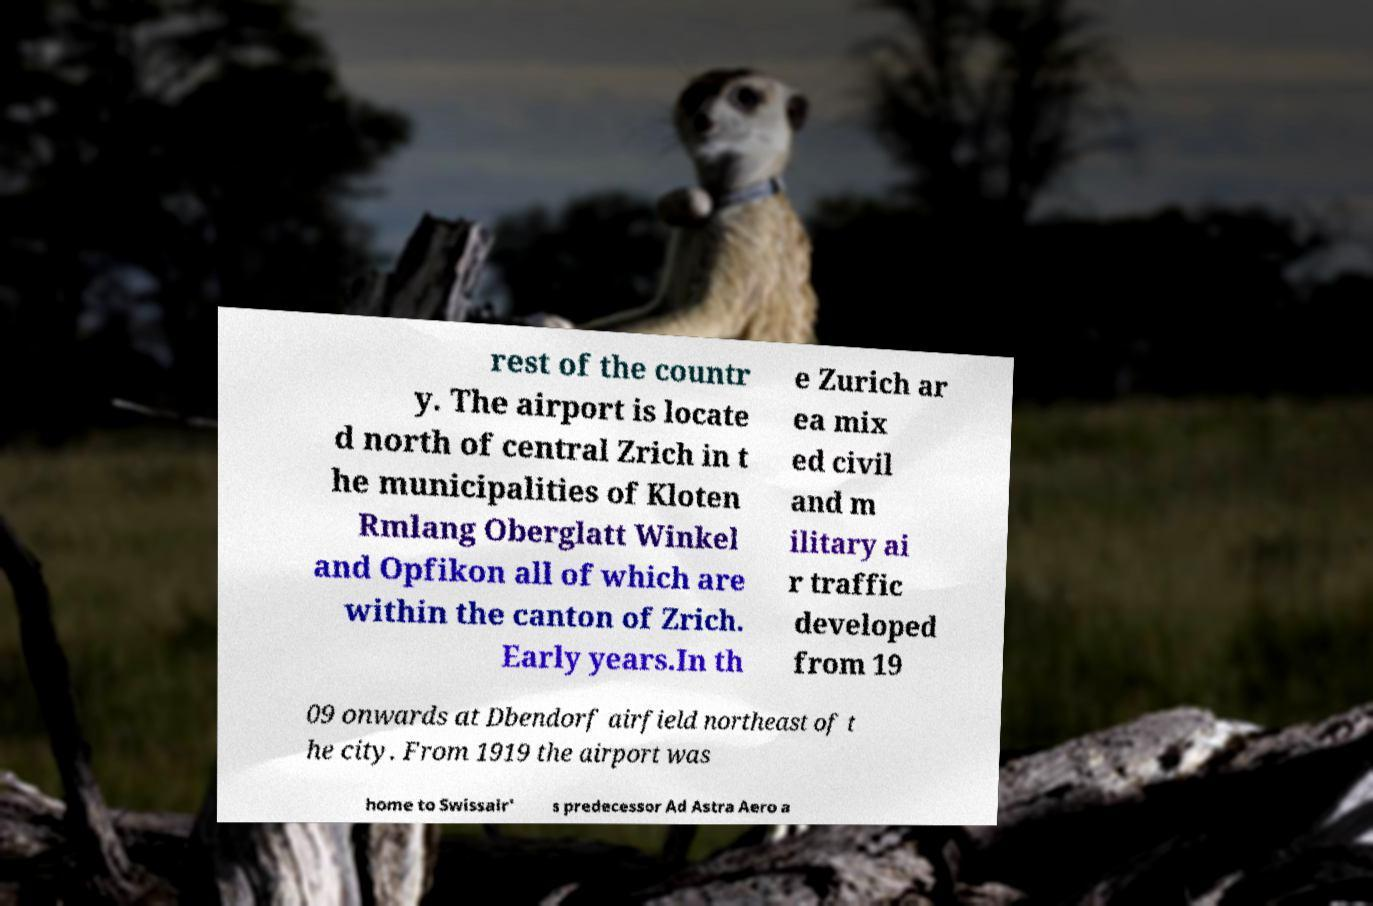There's text embedded in this image that I need extracted. Can you transcribe it verbatim? rest of the countr y. The airport is locate d north of central Zrich in t he municipalities of Kloten Rmlang Oberglatt Winkel and Opfikon all of which are within the canton of Zrich. Early years.In th e Zurich ar ea mix ed civil and m ilitary ai r traffic developed from 19 09 onwards at Dbendorf airfield northeast of t he city. From 1919 the airport was home to Swissair' s predecessor Ad Astra Aero a 